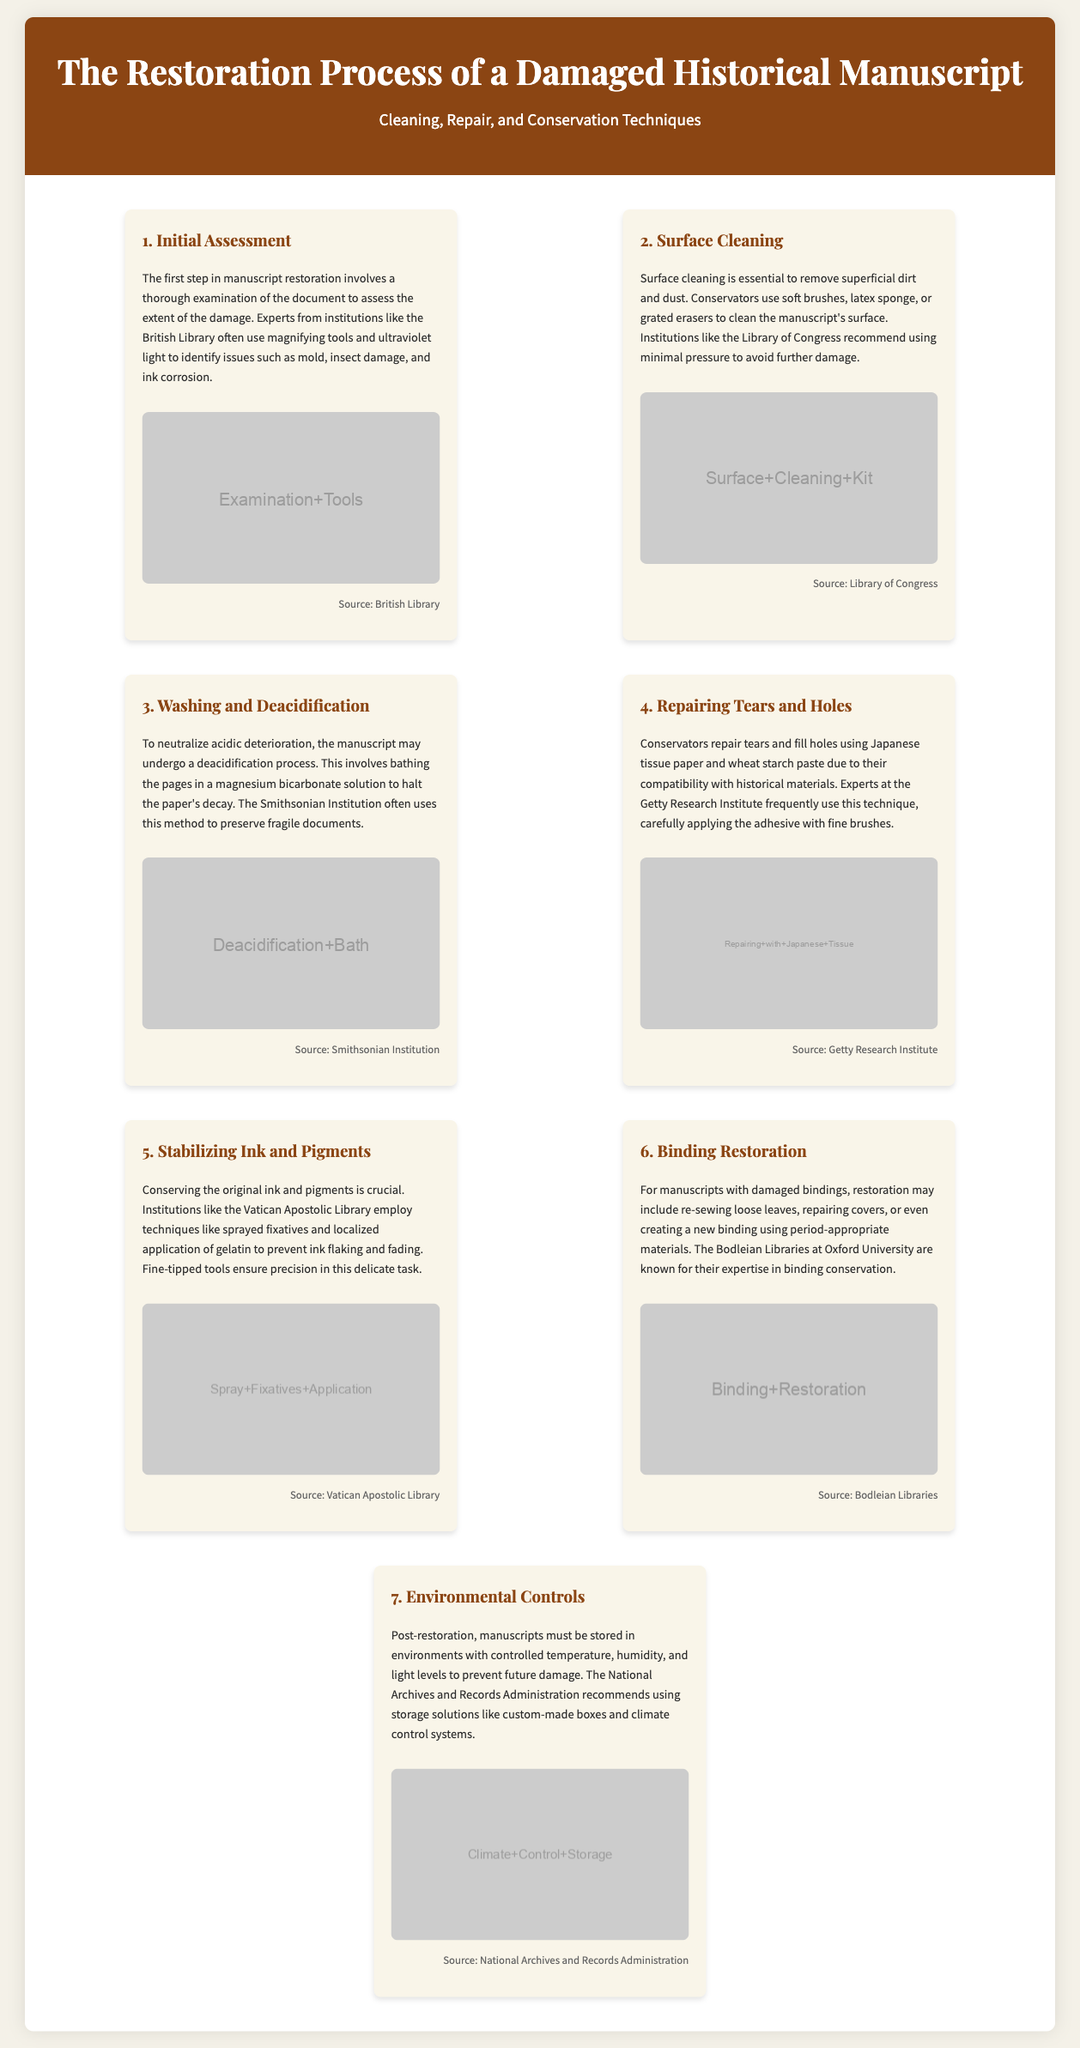what is the first step in the restoration process? The first step in manuscript restoration involves a thorough examination of the document to assess the extent of the damage.
Answer: Initial Assessment which institution uses ultraviolet light for examination? Experts from institutions like the British Library often use magnifying tools and ultraviolet light to identify issues.
Answer: British Library what is used to neutralize acidic deterioration? The manuscript may undergo a deacidification process involving bathing the pages in a solution.
Answer: magnesium bicarbonate solution what material is commonly used for repairing tears? Conservators repair tears and fill holes using Japanese tissue paper and wheat starch paste.
Answer: Japanese tissue paper what is the purpose of environmental controls? Post-restoration, manuscripts must be stored in environments with controlled conditions to prevent future damage.
Answer: prevent future damage how many steps are in the restoration process? There are 7 steps outlined in the restoration process of a damaged historical manuscript.
Answer: 7 steps which library is known for binding conservation? The Bodleian Libraries at Oxford University are known for their expertise in binding conservation.
Answer: Bodleian Libraries what technique is employed to stabilize ink? Techniques like sprayed fixatives and localized application of gelatin are employed.
Answer: sprayed fixatives and localized application of gelatin 